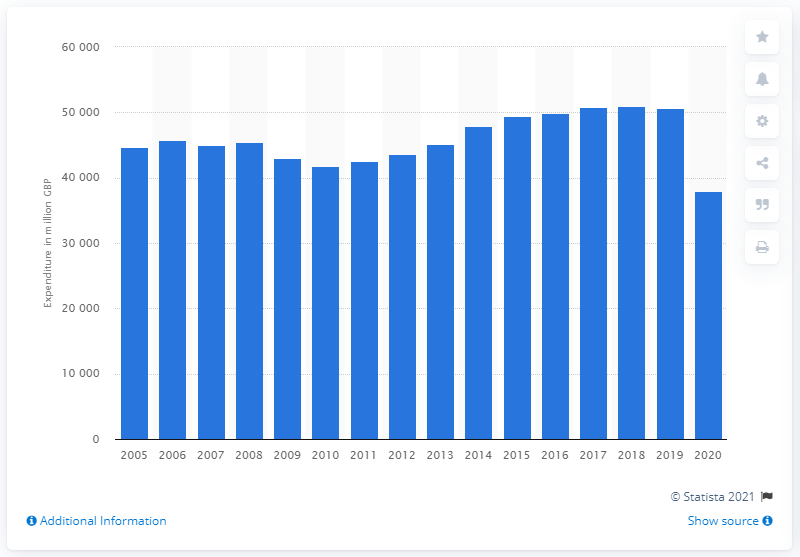Draw attention to some important aspects in this diagram. In 2020, the total expenditure on recreational and cultural services in the United Kingdom was 37,930 GBP. 